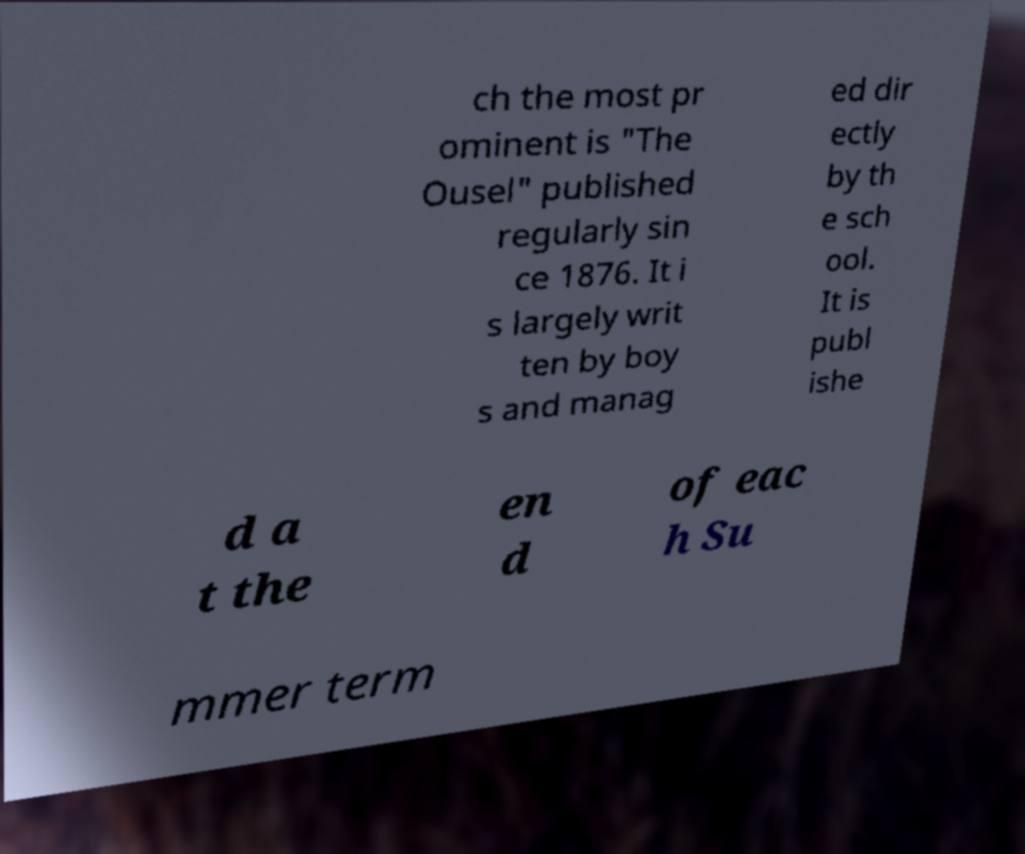For documentation purposes, I need the text within this image transcribed. Could you provide that? ch the most pr ominent is "The Ousel" published regularly sin ce 1876. It i s largely writ ten by boy s and manag ed dir ectly by th e sch ool. It is publ ishe d a t the en d of eac h Su mmer term 